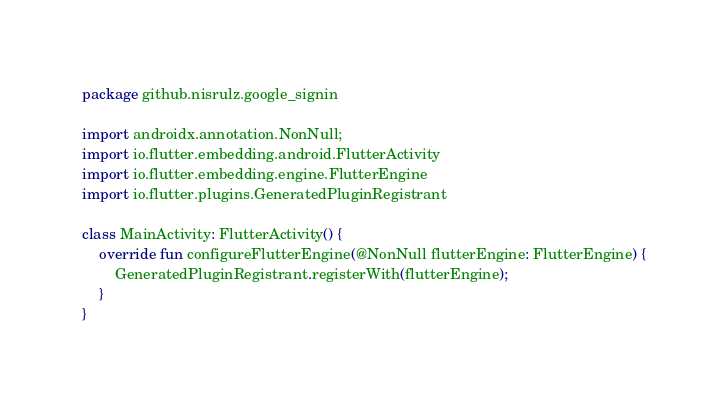<code> <loc_0><loc_0><loc_500><loc_500><_Kotlin_>package github.nisrulz.google_signin

import androidx.annotation.NonNull;
import io.flutter.embedding.android.FlutterActivity
import io.flutter.embedding.engine.FlutterEngine
import io.flutter.plugins.GeneratedPluginRegistrant

class MainActivity: FlutterActivity() {
    override fun configureFlutterEngine(@NonNull flutterEngine: FlutterEngine) {
        GeneratedPluginRegistrant.registerWith(flutterEngine);
    }
}
</code> 